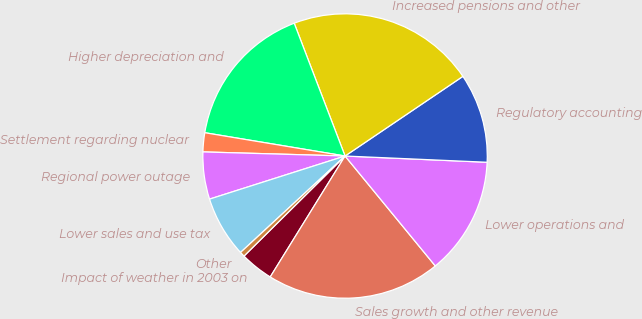Convert chart. <chart><loc_0><loc_0><loc_500><loc_500><pie_chart><fcel>Impact of weather in 2003 on<fcel>Sales growth and other revenue<fcel>Lower operations and<fcel>Regulatory accounting<fcel>Increased pensions and other<fcel>Higher depreciation and<fcel>Settlement regarding nuclear<fcel>Regional power outage<fcel>Lower sales and use tax<fcel>Other<nl><fcel>3.76%<fcel>19.76%<fcel>13.36%<fcel>10.16%<fcel>21.36%<fcel>16.56%<fcel>2.16%<fcel>5.36%<fcel>6.96%<fcel>0.56%<nl></chart> 